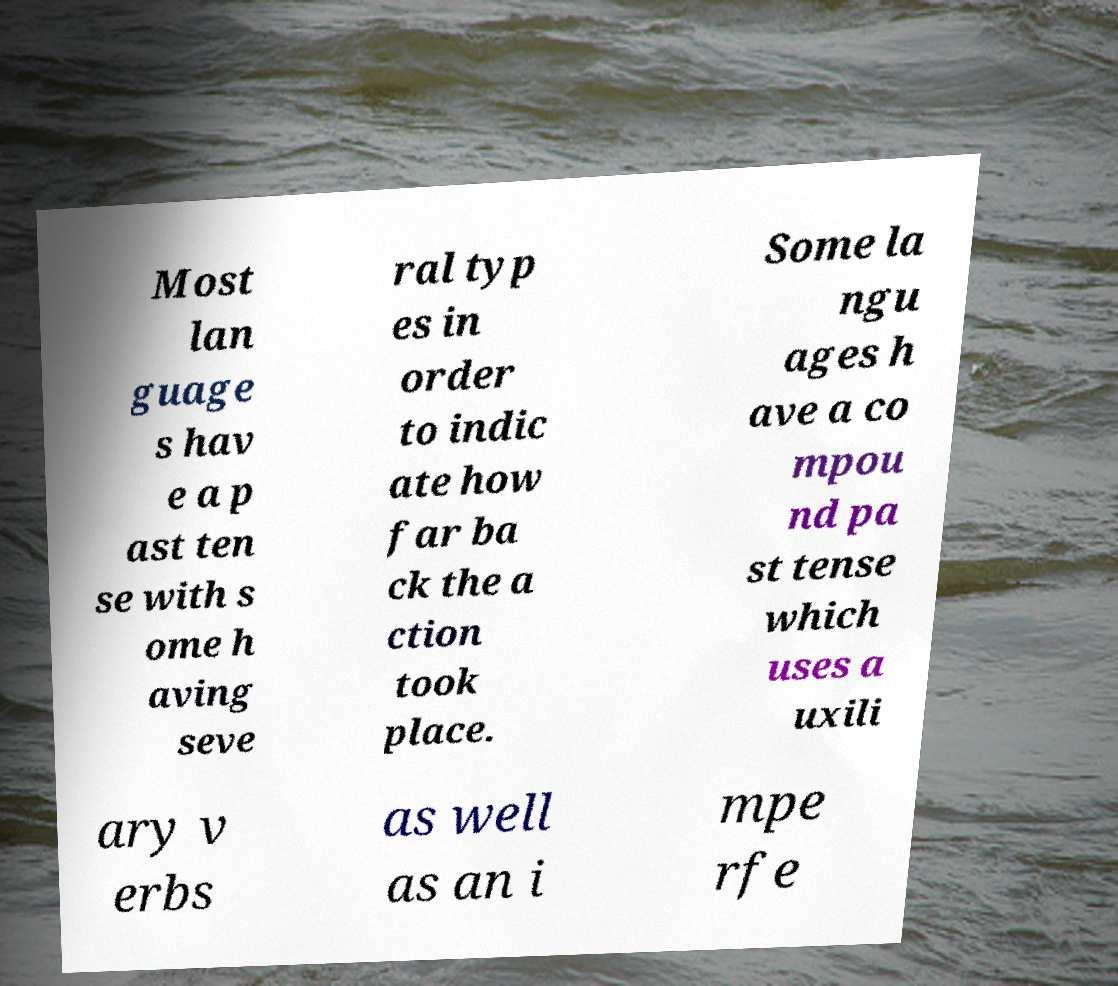Please read and relay the text visible in this image. What does it say? Most lan guage s hav e a p ast ten se with s ome h aving seve ral typ es in order to indic ate how far ba ck the a ction took place. Some la ngu ages h ave a co mpou nd pa st tense which uses a uxili ary v erbs as well as an i mpe rfe 